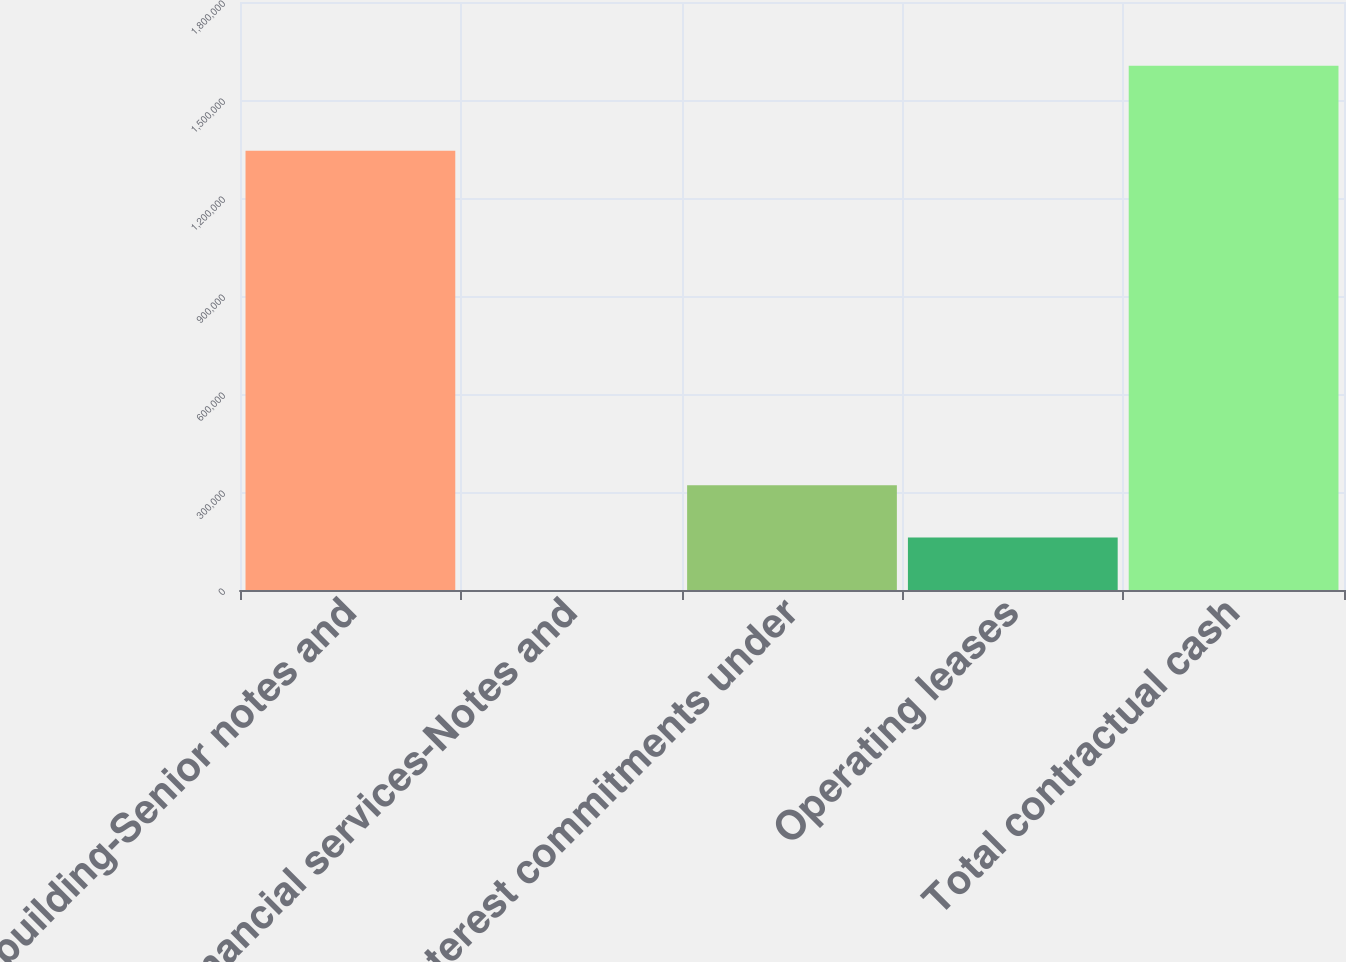Convert chart. <chart><loc_0><loc_0><loc_500><loc_500><bar_chart><fcel>Homebuilding-Senior notes and<fcel>Financial services-Notes and<fcel>Interest commitments under<fcel>Operating leases<fcel>Total contractual cash<nl><fcel>1.34492e+06<fcel>24<fcel>320971<fcel>160498<fcel>1.60476e+06<nl></chart> 